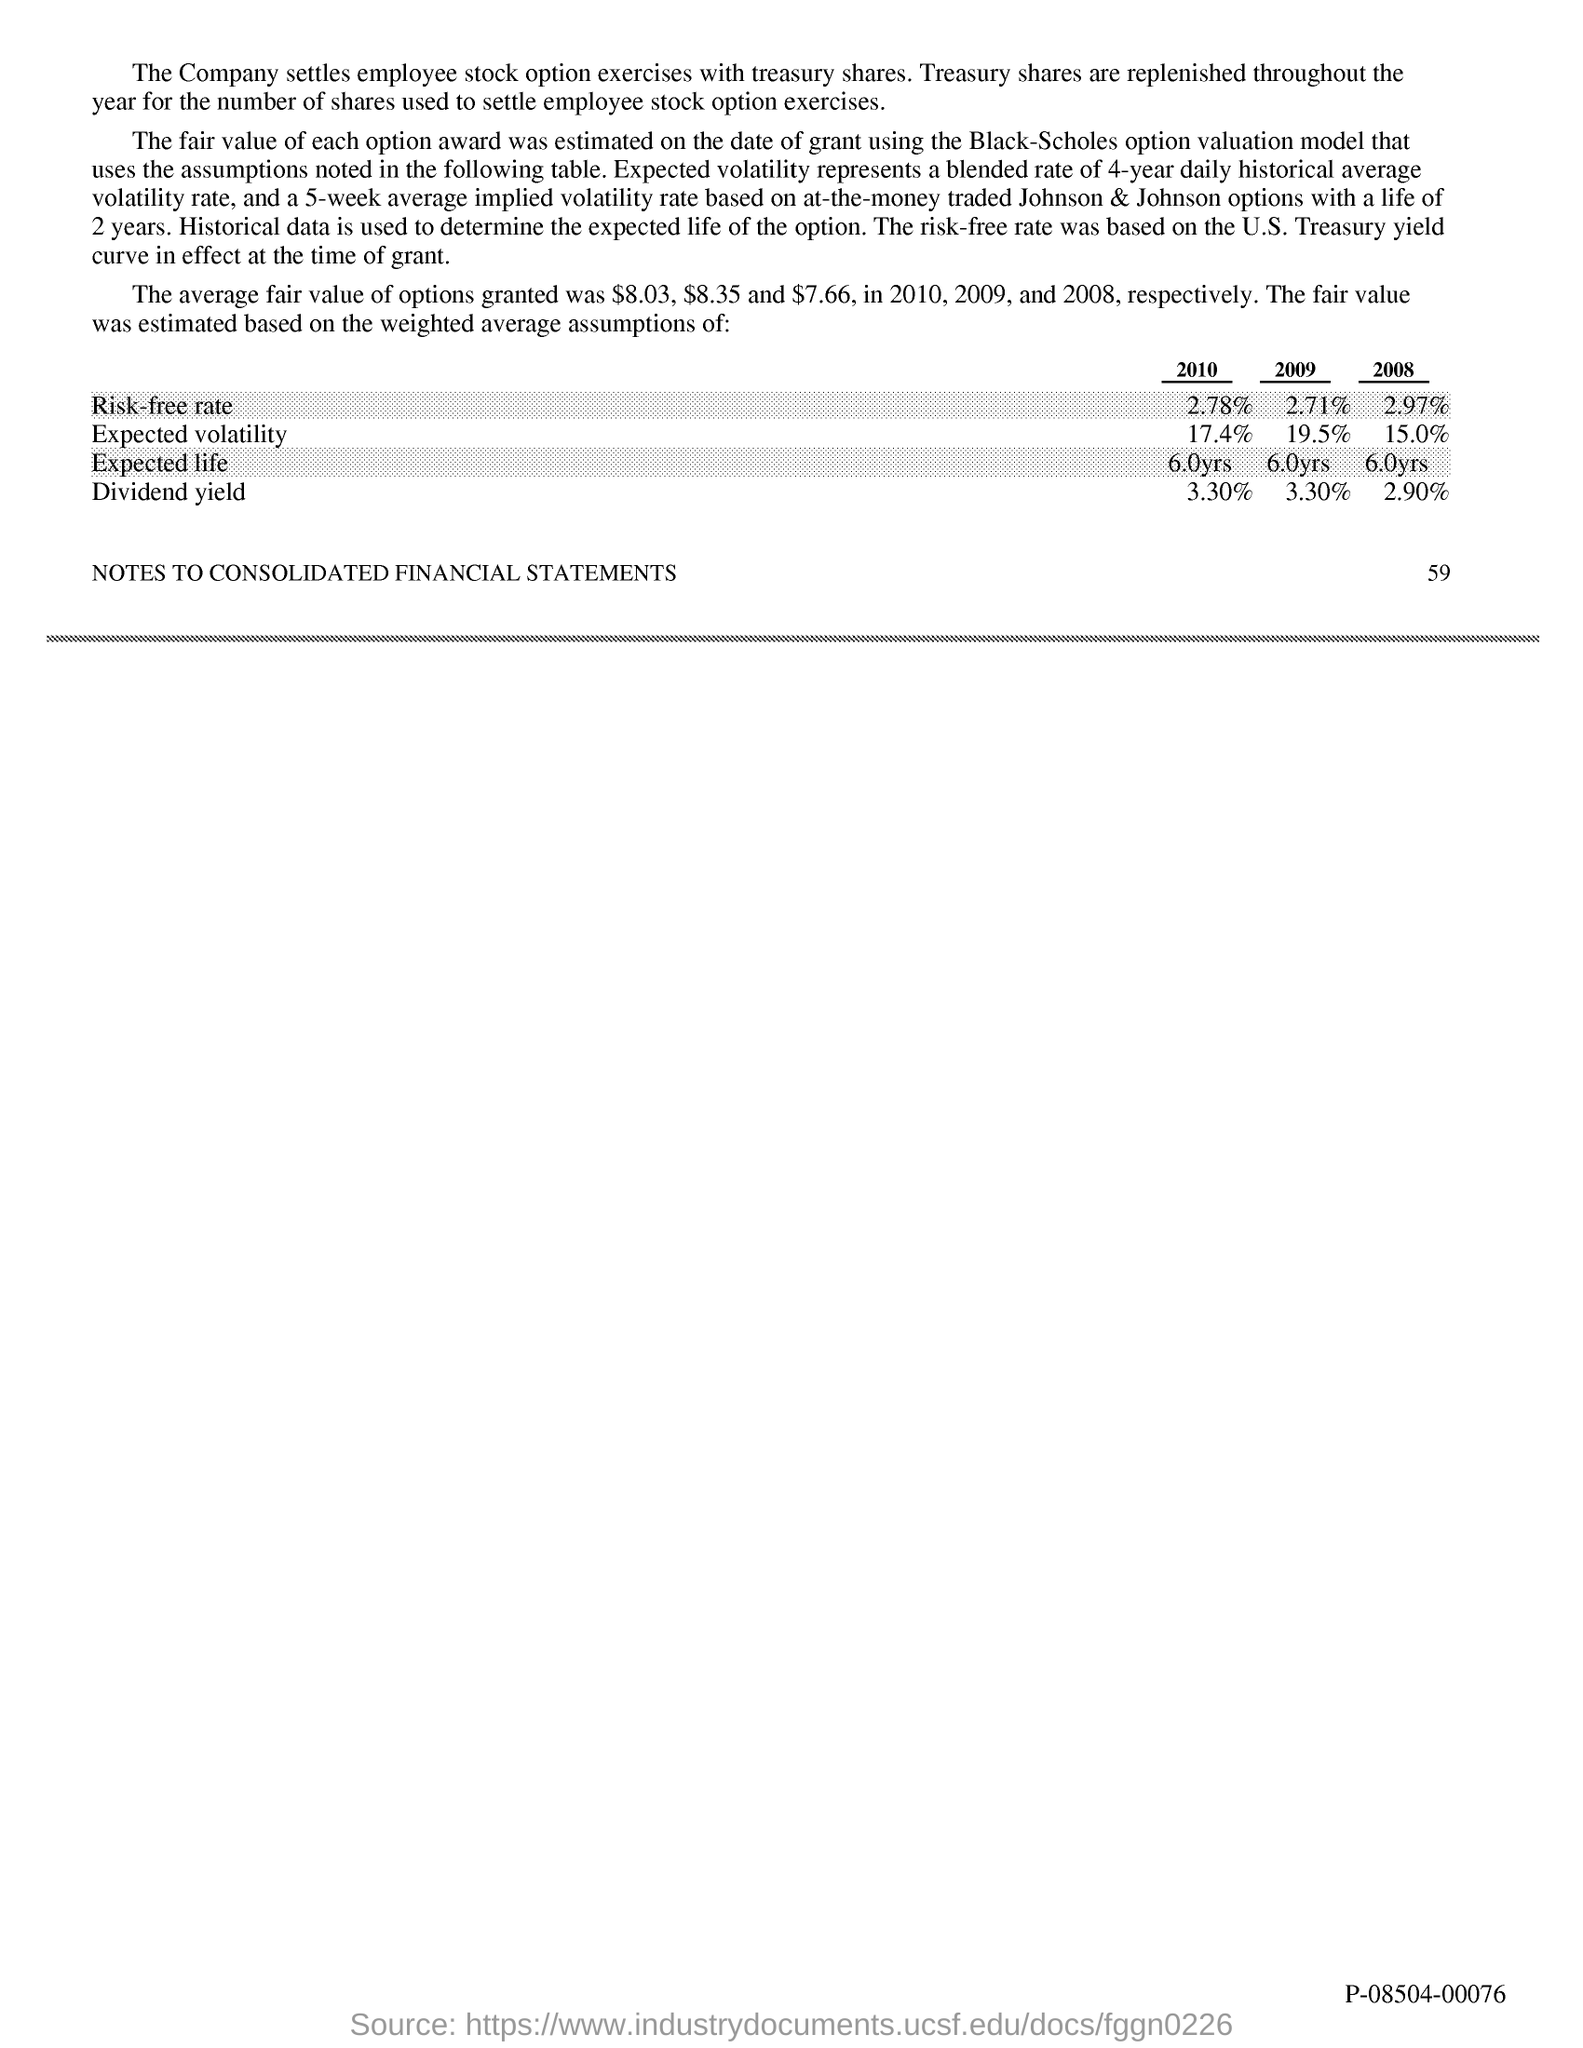What is the Risk-free rate for 2010?
Your answer should be compact. 2.78%. What is the Risk-free rate for 2009?
Offer a very short reply. 2.71%. What is the Risk-free rate for 2008?
Make the answer very short. 2.97%. What is the Expected volatility for 2010?
Keep it short and to the point. 17.4%. What is the Expected volatility for 2009?
Give a very brief answer. 19.5%. What is the Expected volatility for 2008?
Your response must be concise. 15.0%. What is the Expected life for 2010?
Offer a very short reply. 6.0yrs. What is the Expected life for 2009?
Provide a succinct answer. 6.0yrs. What is the Expected life for 2008?
Your response must be concise. 6.0yrs. What is the Dividend yield for 2010?
Provide a short and direct response. 3.30%. 